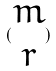<formula> <loc_0><loc_0><loc_500><loc_500>( \begin{matrix} m \\ r \end{matrix} )</formula> 